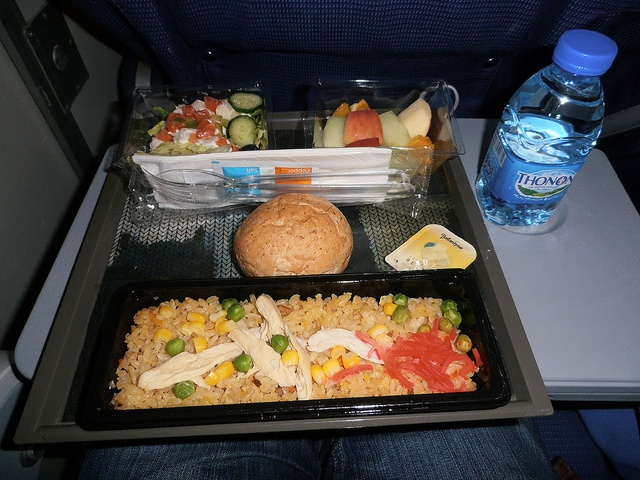Describe the objects in this image and their specific colors. I can see bowl in black and tan tones, people in black, navy, darkblue, and blue tones, bottle in black, blue, and navy tones, apple in black, tan, and brown tones, and fork in black, gray, and darkgray tones in this image. 